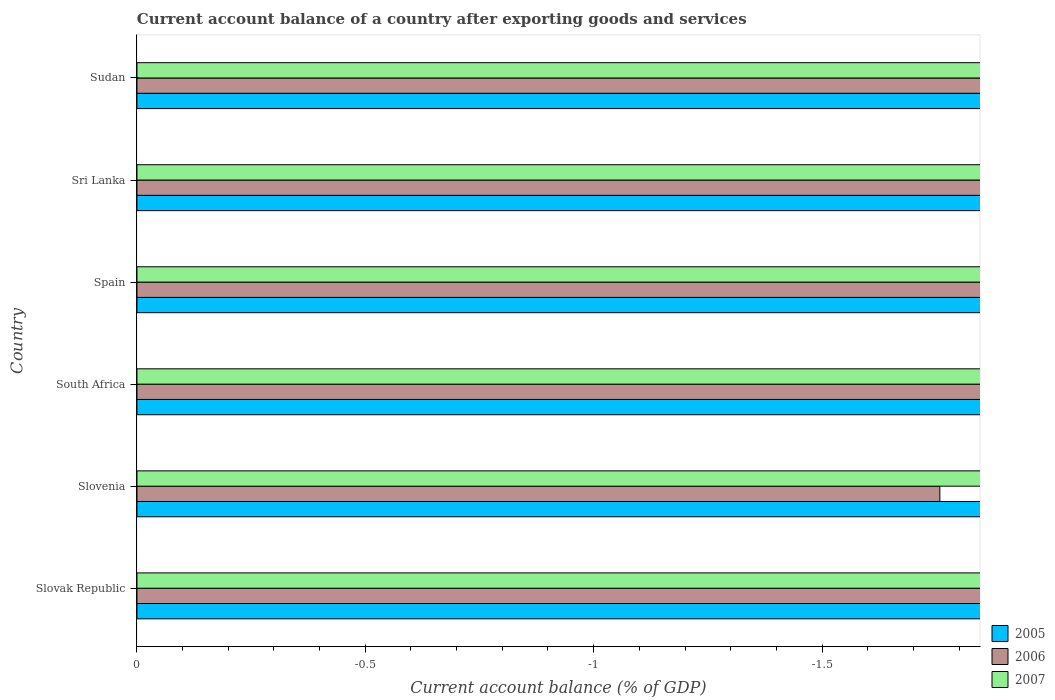Are the number of bars on each tick of the Y-axis equal?
Provide a short and direct response. Yes. What is the label of the 5th group of bars from the top?
Ensure brevity in your answer.  Slovenia. In how many cases, is the number of bars for a given country not equal to the number of legend labels?
Offer a very short reply. 6. What is the account balance in 2006 in Spain?
Give a very brief answer. 0. What is the total account balance in 2005 in the graph?
Provide a short and direct response. 0. In how many countries, is the account balance in 2006 greater than -1.8 %?
Your answer should be compact. 1. In how many countries, is the account balance in 2007 greater than the average account balance in 2007 taken over all countries?
Your answer should be compact. 0. Is it the case that in every country, the sum of the account balance in 2007 and account balance in 2005 is greater than the account balance in 2006?
Give a very brief answer. No. How many bars are there?
Your response must be concise. 0. How many legend labels are there?
Offer a terse response. 3. How are the legend labels stacked?
Offer a very short reply. Vertical. What is the title of the graph?
Make the answer very short. Current account balance of a country after exporting goods and services. Does "1990" appear as one of the legend labels in the graph?
Your answer should be very brief. No. What is the label or title of the X-axis?
Your answer should be very brief. Current account balance (% of GDP). What is the label or title of the Y-axis?
Offer a terse response. Country. What is the Current account balance (% of GDP) of 2005 in Slovak Republic?
Keep it short and to the point. 0. What is the Current account balance (% of GDP) of 2006 in Slovak Republic?
Give a very brief answer. 0. What is the Current account balance (% of GDP) in 2007 in Slovak Republic?
Make the answer very short. 0. What is the Current account balance (% of GDP) in 2005 in South Africa?
Make the answer very short. 0. What is the Current account balance (% of GDP) of 2007 in Spain?
Provide a succinct answer. 0. What is the Current account balance (% of GDP) in 2006 in Sri Lanka?
Give a very brief answer. 0. What is the Current account balance (% of GDP) of 2006 in Sudan?
Offer a terse response. 0. What is the total Current account balance (% of GDP) in 2005 in the graph?
Give a very brief answer. 0. What is the average Current account balance (% of GDP) of 2005 per country?
Give a very brief answer. 0. What is the average Current account balance (% of GDP) of 2006 per country?
Your response must be concise. 0. What is the average Current account balance (% of GDP) of 2007 per country?
Make the answer very short. 0. 